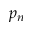Convert formula to latex. <formula><loc_0><loc_0><loc_500><loc_500>p _ { n }</formula> 